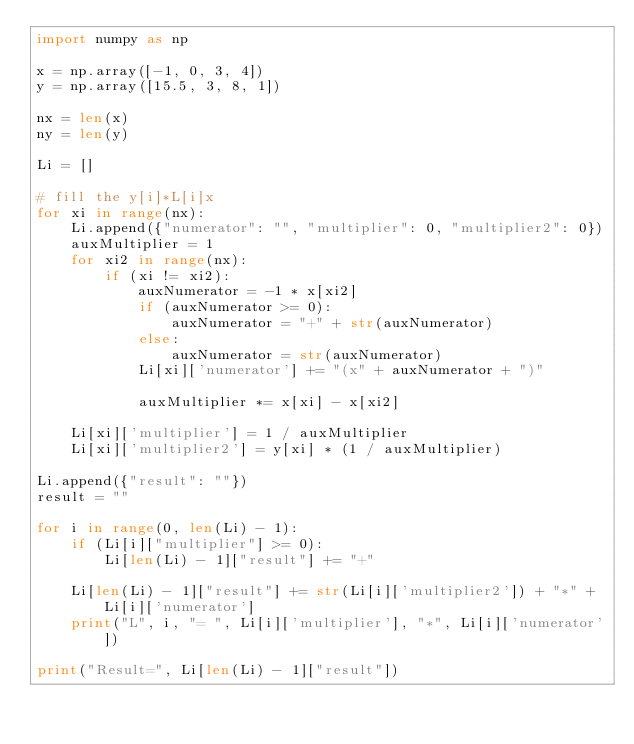Convert code to text. <code><loc_0><loc_0><loc_500><loc_500><_Python_>import numpy as np

x = np.array([-1, 0, 3, 4])
y = np.array([15.5, 3, 8, 1])

nx = len(x)
ny = len(y)

Li = []

# fill the y[i]*L[i]x
for xi in range(nx):
    Li.append({"numerator": "", "multiplier": 0, "multiplier2": 0})
    auxMultiplier = 1
    for xi2 in range(nx):
        if (xi != xi2):
            auxNumerator = -1 * x[xi2]
            if (auxNumerator >= 0):
                auxNumerator = "+" + str(auxNumerator)
            else:
                auxNumerator = str(auxNumerator)
            Li[xi]['numerator'] += "(x" + auxNumerator + ")"

            auxMultiplier *= x[xi] - x[xi2]

    Li[xi]['multiplier'] = 1 / auxMultiplier
    Li[xi]['multiplier2'] = y[xi] * (1 / auxMultiplier)

Li.append({"result": ""})
result = ""

for i in range(0, len(Li) - 1):
    if (Li[i]["multiplier"] >= 0):
        Li[len(Li) - 1]["result"] += "+"

    Li[len(Li) - 1]["result"] += str(Li[i]['multiplier2']) + "*" + Li[i]['numerator']
    print("L", i, "= ", Li[i]['multiplier'], "*", Li[i]['numerator'])

print("Result=", Li[len(Li) - 1]["result"])
</code> 